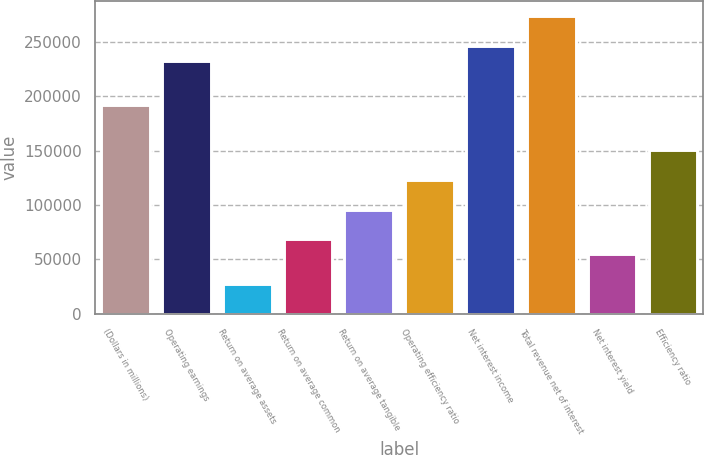Convert chart. <chart><loc_0><loc_0><loc_500><loc_500><bar_chart><fcel>(Dollars in millions)<fcel>Operating earnings<fcel>Return on average assets<fcel>Return on average common<fcel>Return on average tangible<fcel>Operating efficiency ratio<fcel>Net interest income<fcel>Total revenue net of interest<fcel>Net interest yield<fcel>Efficiency ratio<nl><fcel>191327<fcel>232325<fcel>27332.4<fcel>68331<fcel>95663.4<fcel>122996<fcel>245992<fcel>273324<fcel>54664.8<fcel>150328<nl></chart> 